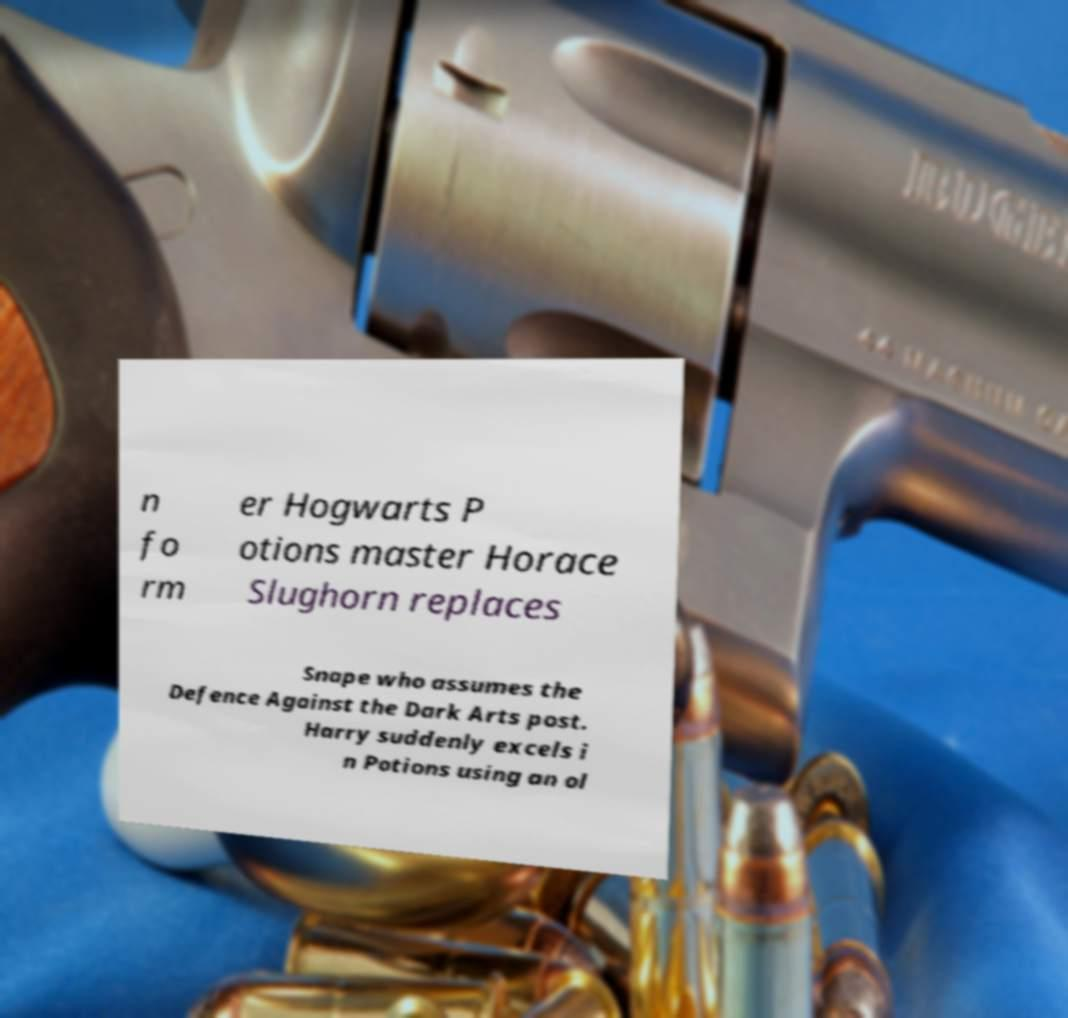There's text embedded in this image that I need extracted. Can you transcribe it verbatim? n fo rm er Hogwarts P otions master Horace Slughorn replaces Snape who assumes the Defence Against the Dark Arts post. Harry suddenly excels i n Potions using an ol 